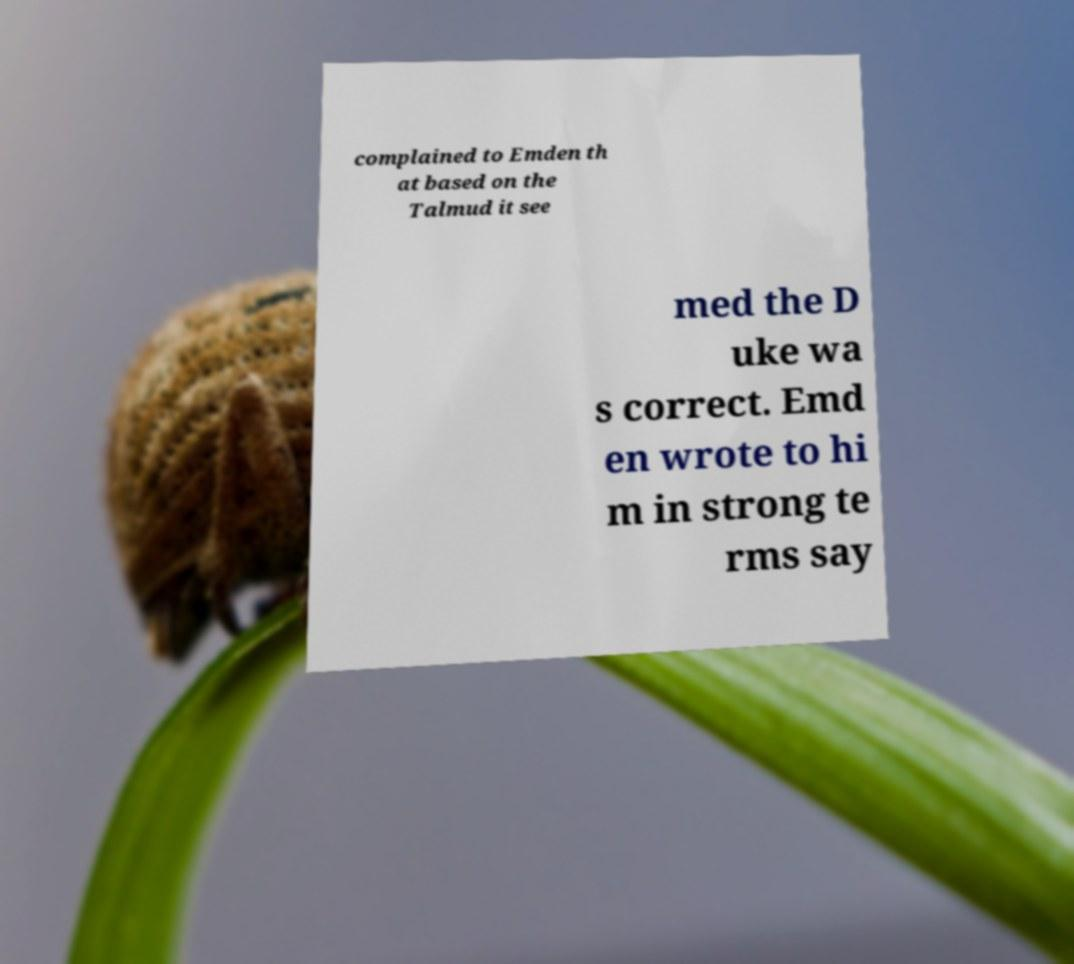Could you assist in decoding the text presented in this image and type it out clearly? complained to Emden th at based on the Talmud it see med the D uke wa s correct. Emd en wrote to hi m in strong te rms say 